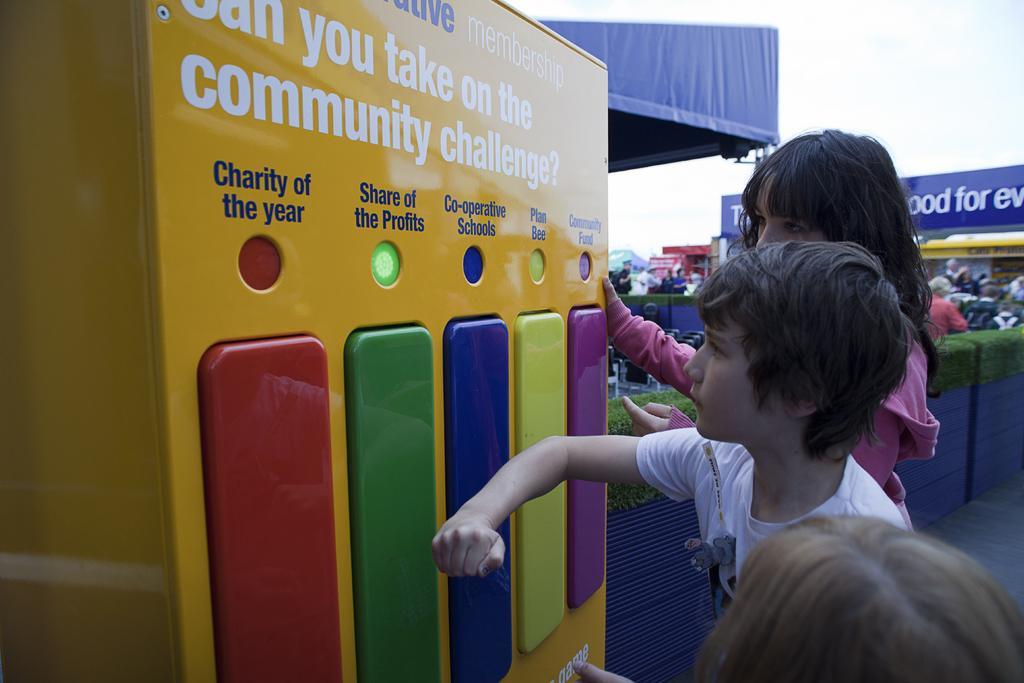Describe this image in one or two sentences. In this image in the center there are persons standing. On the left side there is a machine which is yellow in colour and there are some text written on it. In the background there is a tent which is blue in colour and there is a banner with some text written on it and there are persons. 